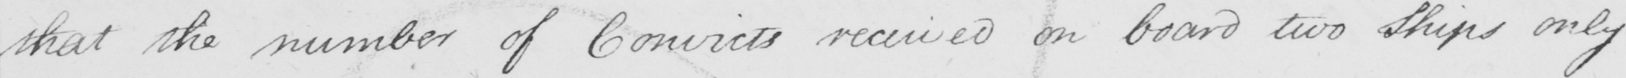Please provide the text content of this handwritten line. that the number of Convicts received on board two ships only 